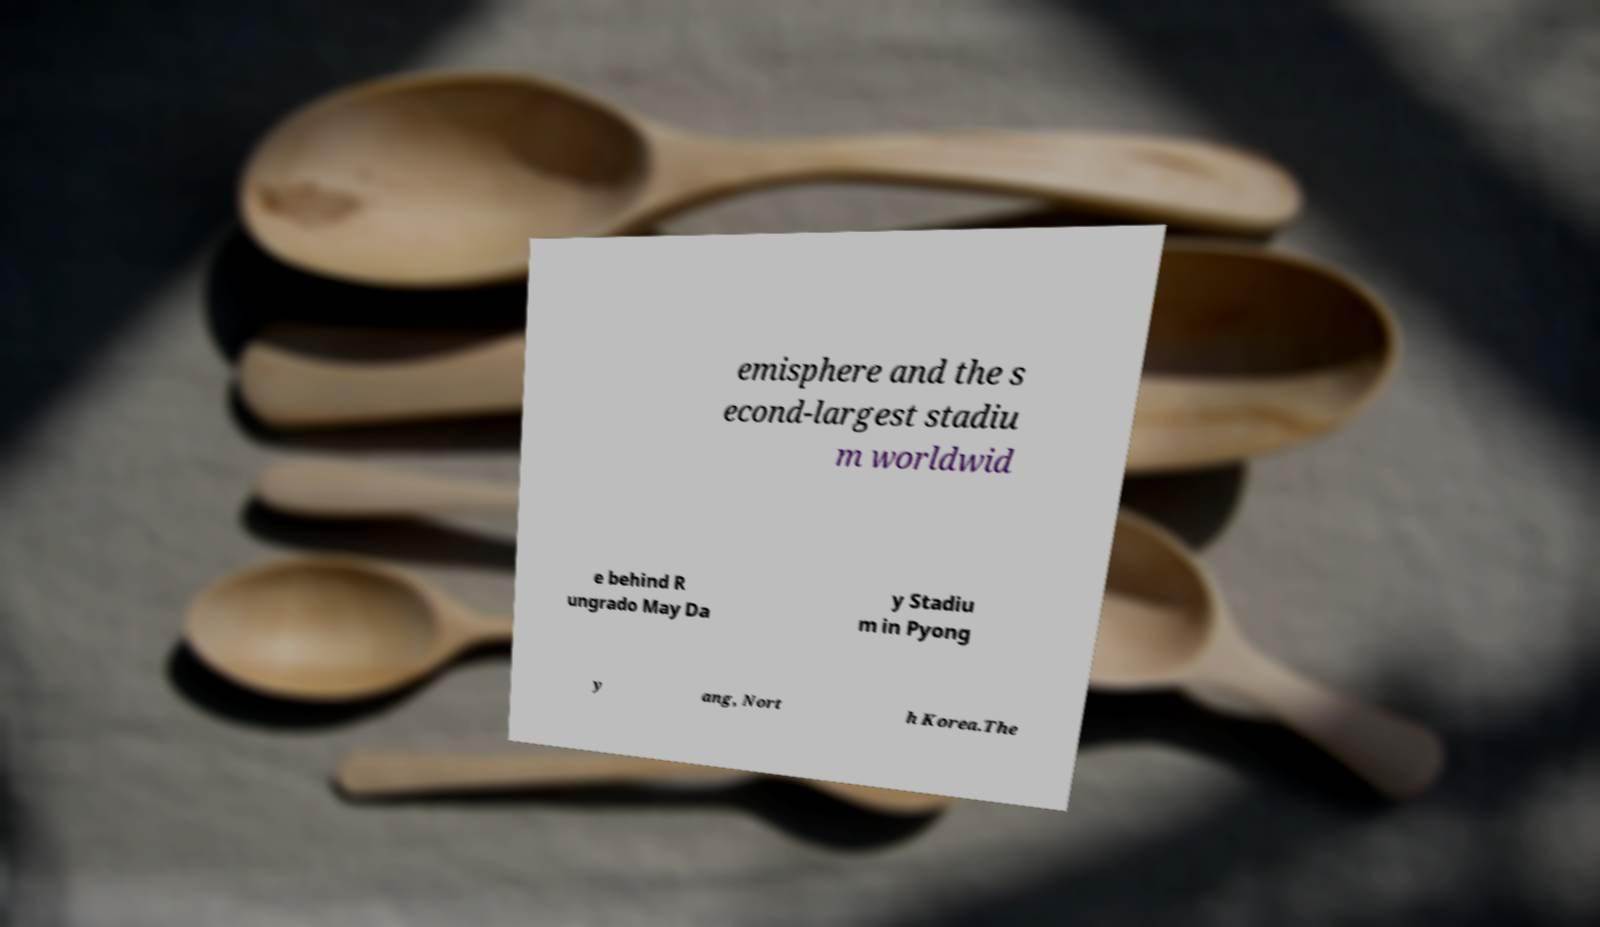Could you assist in decoding the text presented in this image and type it out clearly? emisphere and the s econd-largest stadiu m worldwid e behind R ungrado May Da y Stadiu m in Pyong y ang, Nort h Korea.The 